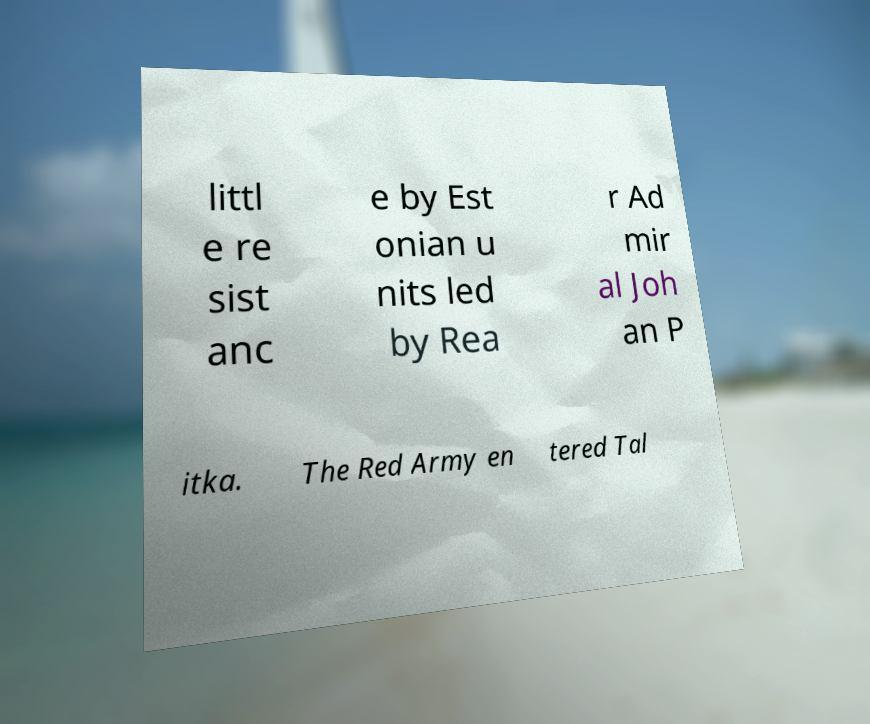I need the written content from this picture converted into text. Can you do that? littl e re sist anc e by Est onian u nits led by Rea r Ad mir al Joh an P itka. The Red Army en tered Tal 